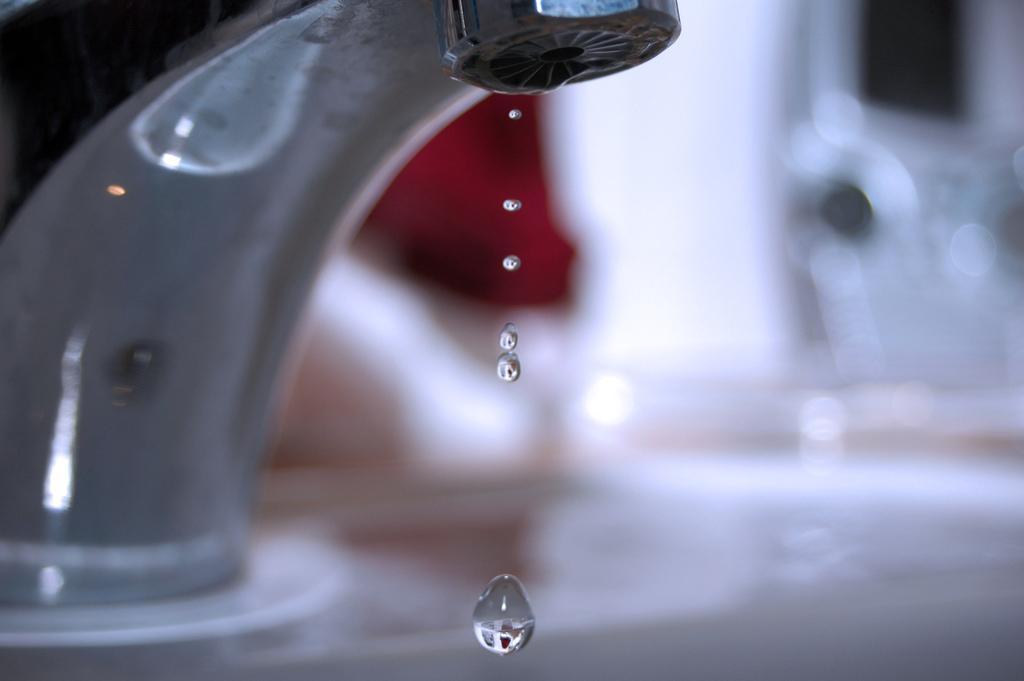Describe this image in one or two sentences. In this picture we can see a tap and water drops. There is a blur background. 